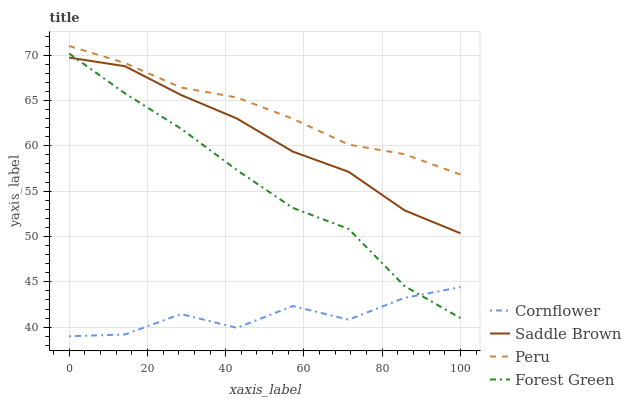Does Cornflower have the minimum area under the curve?
Answer yes or no. Yes. Does Peru have the maximum area under the curve?
Answer yes or no. Yes. Does Forest Green have the minimum area under the curve?
Answer yes or no. No. Does Forest Green have the maximum area under the curve?
Answer yes or no. No. Is Peru the smoothest?
Answer yes or no. Yes. Is Cornflower the roughest?
Answer yes or no. Yes. Is Forest Green the smoothest?
Answer yes or no. No. Is Forest Green the roughest?
Answer yes or no. No. Does Cornflower have the lowest value?
Answer yes or no. Yes. Does Forest Green have the lowest value?
Answer yes or no. No. Does Peru have the highest value?
Answer yes or no. Yes. Does Forest Green have the highest value?
Answer yes or no. No. Is Cornflower less than Peru?
Answer yes or no. Yes. Is Peru greater than Saddle Brown?
Answer yes or no. Yes. Does Saddle Brown intersect Forest Green?
Answer yes or no. Yes. Is Saddle Brown less than Forest Green?
Answer yes or no. No. Is Saddle Brown greater than Forest Green?
Answer yes or no. No. Does Cornflower intersect Peru?
Answer yes or no. No. 